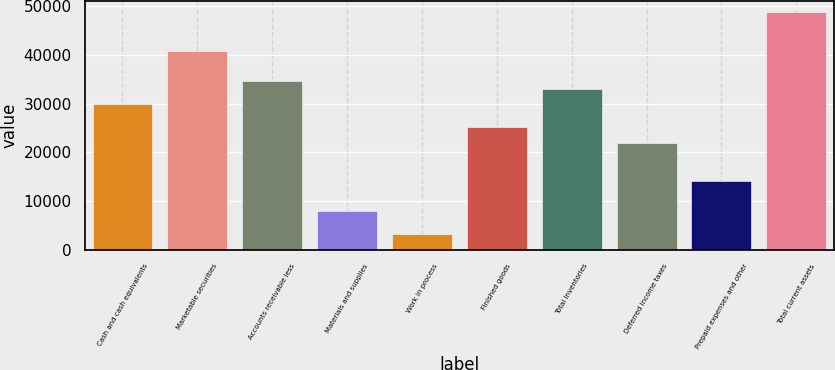Convert chart. <chart><loc_0><loc_0><loc_500><loc_500><bar_chart><fcel>Cash and cash equivalents<fcel>Marketable securities<fcel>Accounts receivable less<fcel>Materials and supplies<fcel>Work in process<fcel>Finished goods<fcel>Total inventories<fcel>Deferred income taxes<fcel>Prepaid expenses and other<fcel>Total current assets<nl><fcel>29889.2<fcel>40891.8<fcel>34604.6<fcel>7884<fcel>3168.6<fcel>25173.8<fcel>33032.8<fcel>22030.2<fcel>14171.2<fcel>48750.8<nl></chart> 